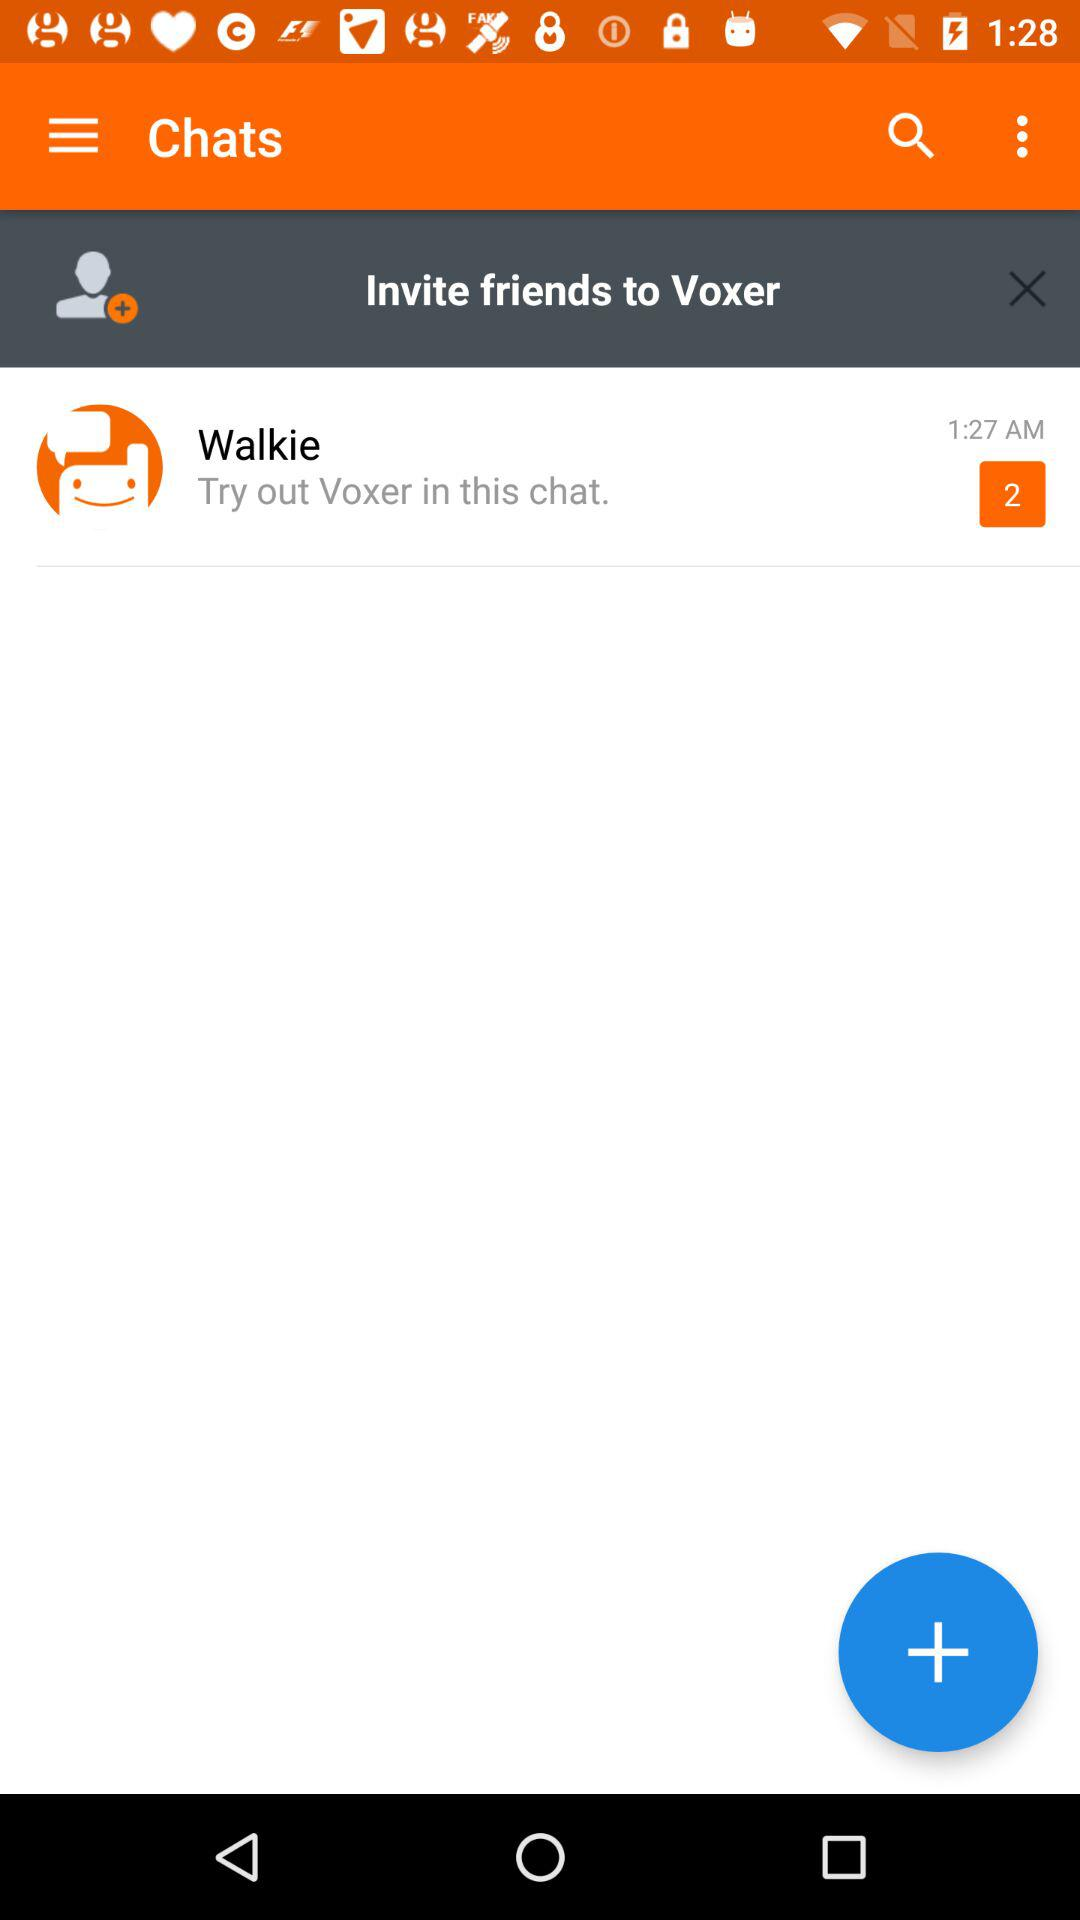What is the time here? The time here is 1:27 AM. 